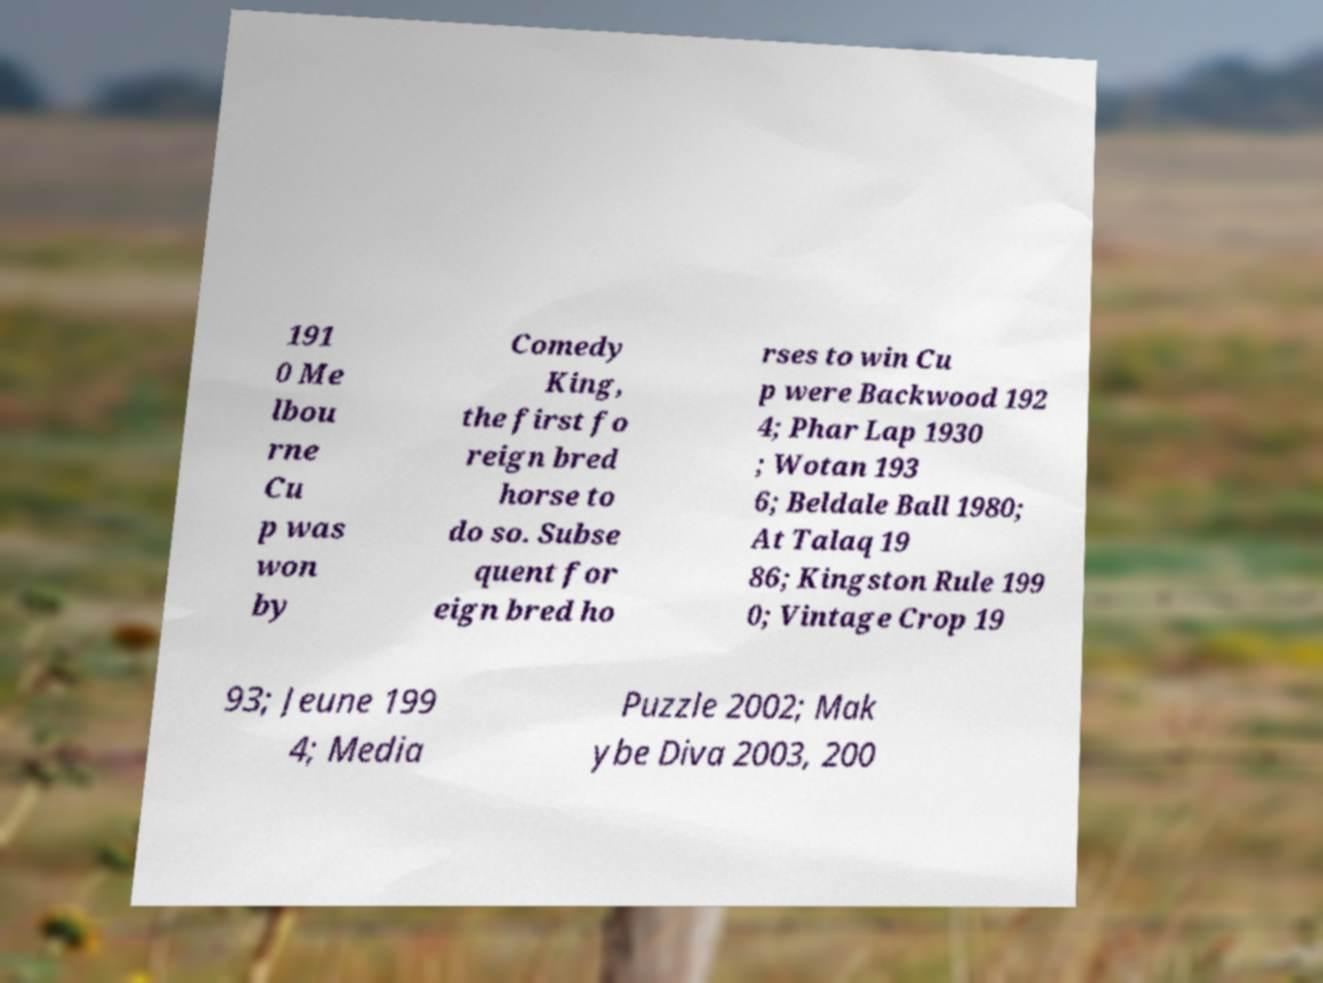There's text embedded in this image that I need extracted. Can you transcribe it verbatim? 191 0 Me lbou rne Cu p was won by Comedy King, the first fo reign bred horse to do so. Subse quent for eign bred ho rses to win Cu p were Backwood 192 4; Phar Lap 1930 ; Wotan 193 6; Beldale Ball 1980; At Talaq 19 86; Kingston Rule 199 0; Vintage Crop 19 93; Jeune 199 4; Media Puzzle 2002; Mak ybe Diva 2003, 200 